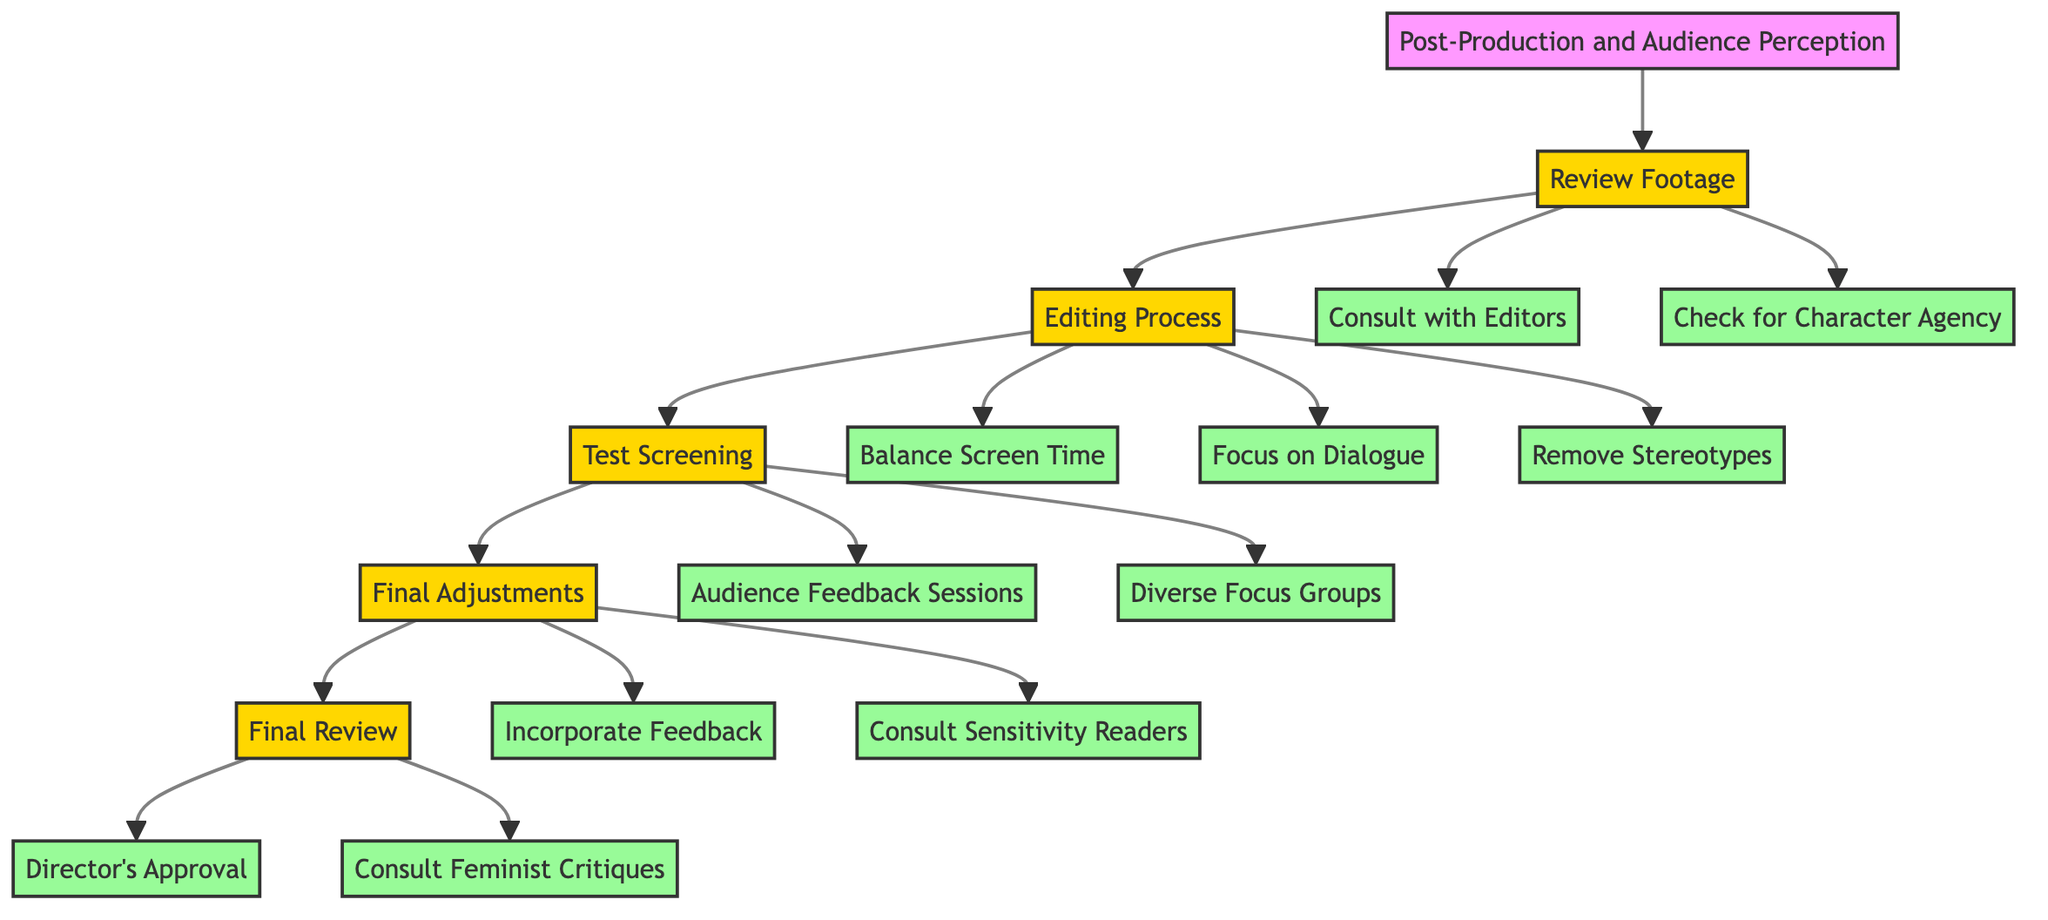What is the title of the clinical pathway? The title is prominently displayed at the top of the diagram and summarizes the overall focus of the pathway, which is on post-production and audience perception regarding female characters.
Answer: Post-Production and Audience Perception: Ensuring the Strength of Female Characters in the Final Cut How many main steps are in the clinical pathway? Counting the main steps in the diagram, we identify five key processes outlined, which include Review Footage, Editing Process, Test Screening, Final Adjustments, and Final Review.
Answer: 5 What is the first sub-step under Review Footage? By analyzing the sub-steps connected to the first main step, it becomes clear that the first listed sub-step directly following Review Footage is to consult with editors.
Answer: Consult with Editors Which step includes audience feedback sessions? Tracing the connections in the diagram leads us through the steps to Test Screening, where audience feedback sessions are explicitly listed as a sub-step.
Answer: Test Screening What are the last sub-steps in the Final Review? The Final Review step has two sub-steps, which are both crucial for the final evaluation. They are Director's Approval and Consult Feminist Critiques, and we can see that these are linked to the last step of the pathway.
Answer: Director's Approval and Consult Feminist Critiques What is the relationship between Editing Process and Test Screening? The diagram shows a direct progression from Editing Process to Test Screening, illustrating that after the editing of the film is completed, the next critical phase involves testing it with an audience.
Answer: Sequential relationship How many sub-steps are there in the Editing Process? By reviewing the sub-steps connected to the Editing Process, we discover there are three distinct sub-steps: Balance Screen Time, Focus on Dialogue, and Remove Stereotypes.
Answer: 3 Which step focuses on character agency? The Review Footage step includes a specific sub-step that emphasizes checking for character agency to ensure female characters are driving their own storylines, highlighting its importance in the early stages of the process.
Answer: Review Footage How is audience feedback incorporated in the clinical pathway? The pathway shows that audience feedback is gathered during the Test Screening phase, and it suggests that the feedback is later addressed in the Final Adjustments step, demonstrating the importance of external perspectives in shaping the final cut.
Answer: Incorporated in Final Adjustments 